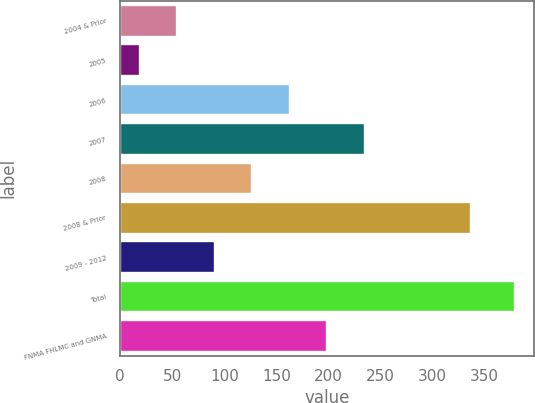Convert chart to OTSL. <chart><loc_0><loc_0><loc_500><loc_500><bar_chart><fcel>2004 & Prior<fcel>2005<fcel>2006<fcel>2007<fcel>2008<fcel>2008 & Prior<fcel>2009 - 2012<fcel>Total<fcel>FNMA FHLMC and GNMA<nl><fcel>55<fcel>19<fcel>163<fcel>235<fcel>127<fcel>337<fcel>91<fcel>379<fcel>199<nl></chart> 